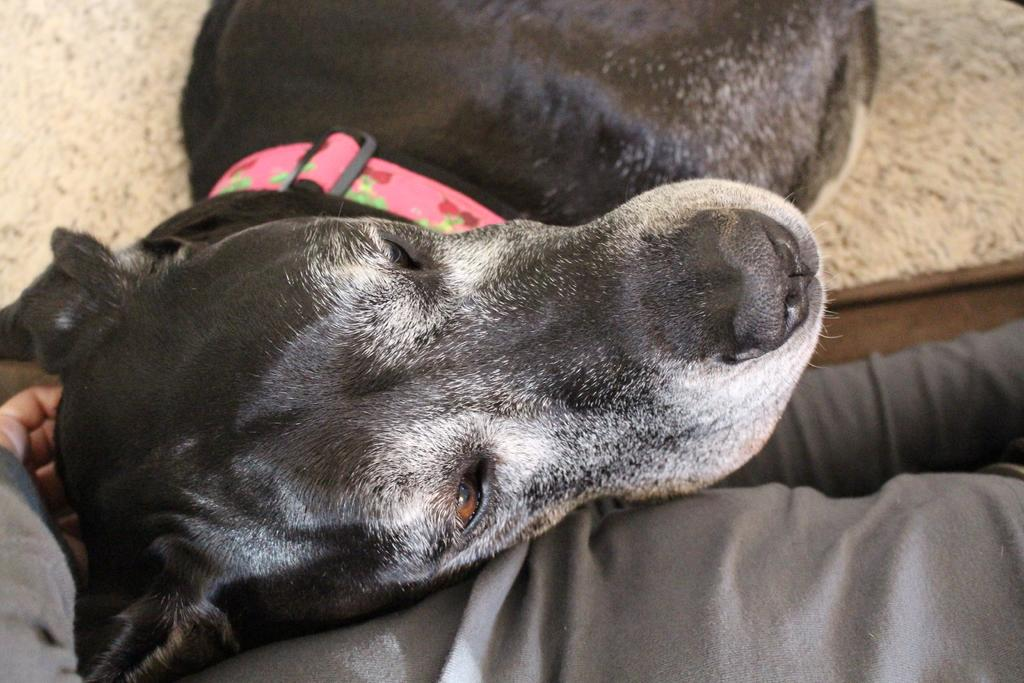What type of animal is in the image? There is a dog in the image. What is the dog doing in the image? The dog has its head on a person's lap. Is the dog wearing any accessories in the image? Yes, the dog is wearing a belt. Can you see any visible veins on the dog in the image? There is no mention of visible veins on the dog in the image, and it is not common to see veins on a dog's body. 